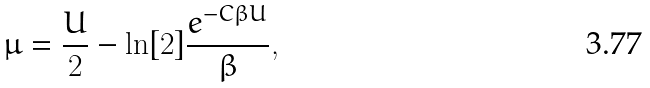<formula> <loc_0><loc_0><loc_500><loc_500>\mu = \frac { U } { 2 } - \ln [ 2 ] \frac { e ^ { - C \beta U } } { \beta } ,</formula> 